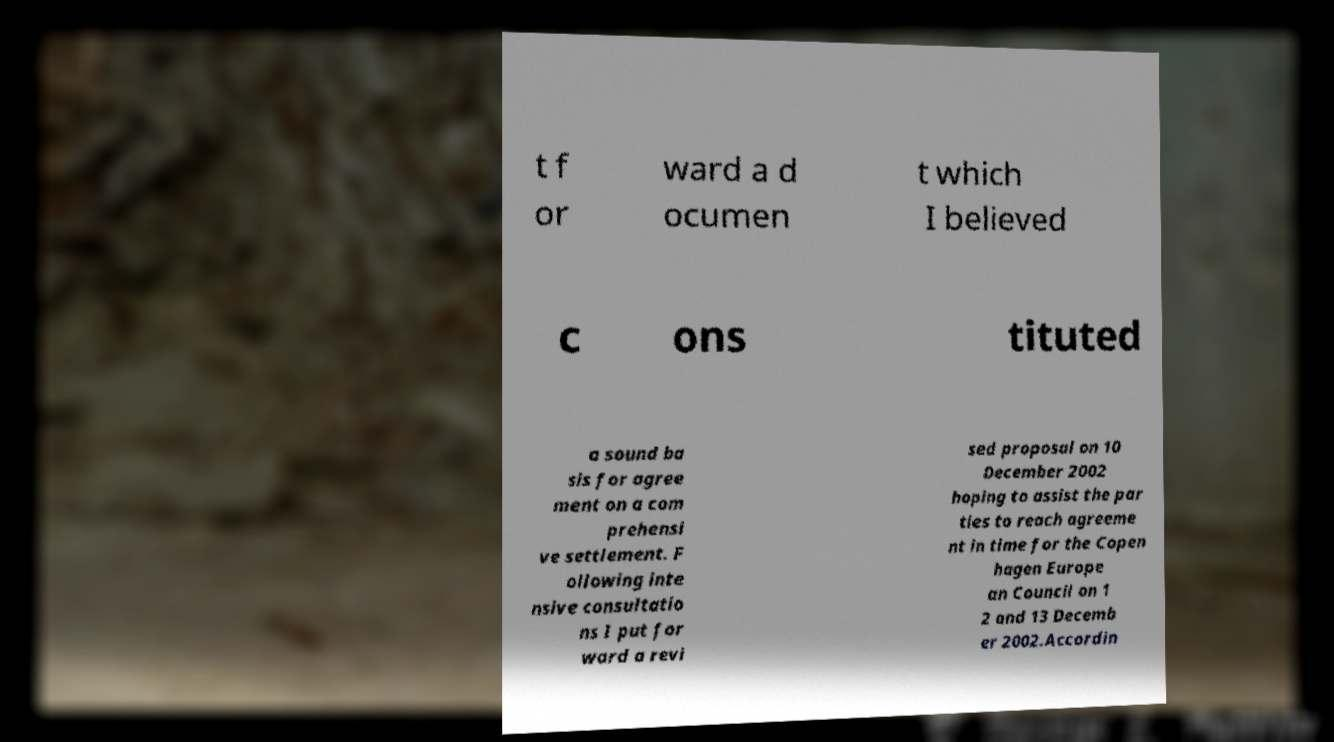Can you read and provide the text displayed in the image?This photo seems to have some interesting text. Can you extract and type it out for me? t f or ward a d ocumen t which I believed c ons tituted a sound ba sis for agree ment on a com prehensi ve settlement. F ollowing inte nsive consultatio ns I put for ward a revi sed proposal on 10 December 2002 hoping to assist the par ties to reach agreeme nt in time for the Copen hagen Europe an Council on 1 2 and 13 Decemb er 2002.Accordin 